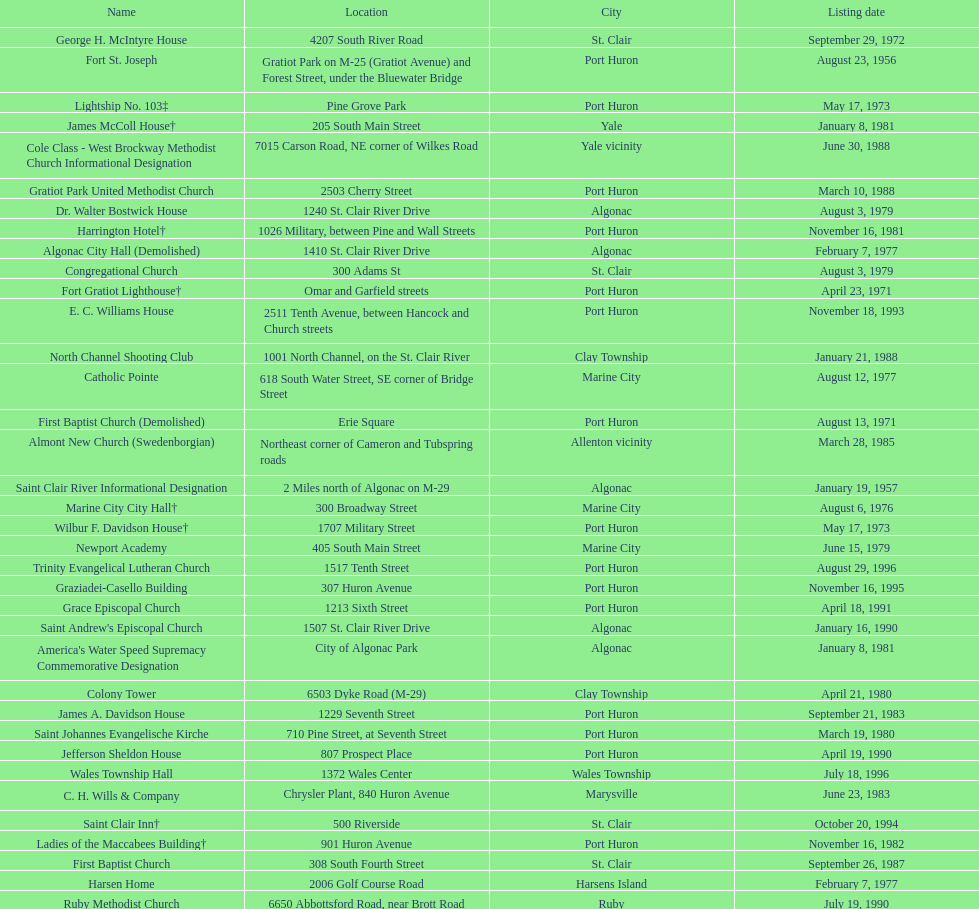Which city is home to the greatest number of historic sites, existing or demolished? Port Huron. 